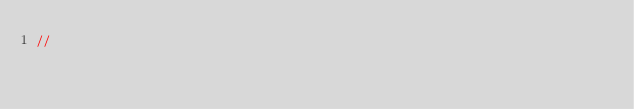<code> <loc_0><loc_0><loc_500><loc_500><_C#_>// </code> 